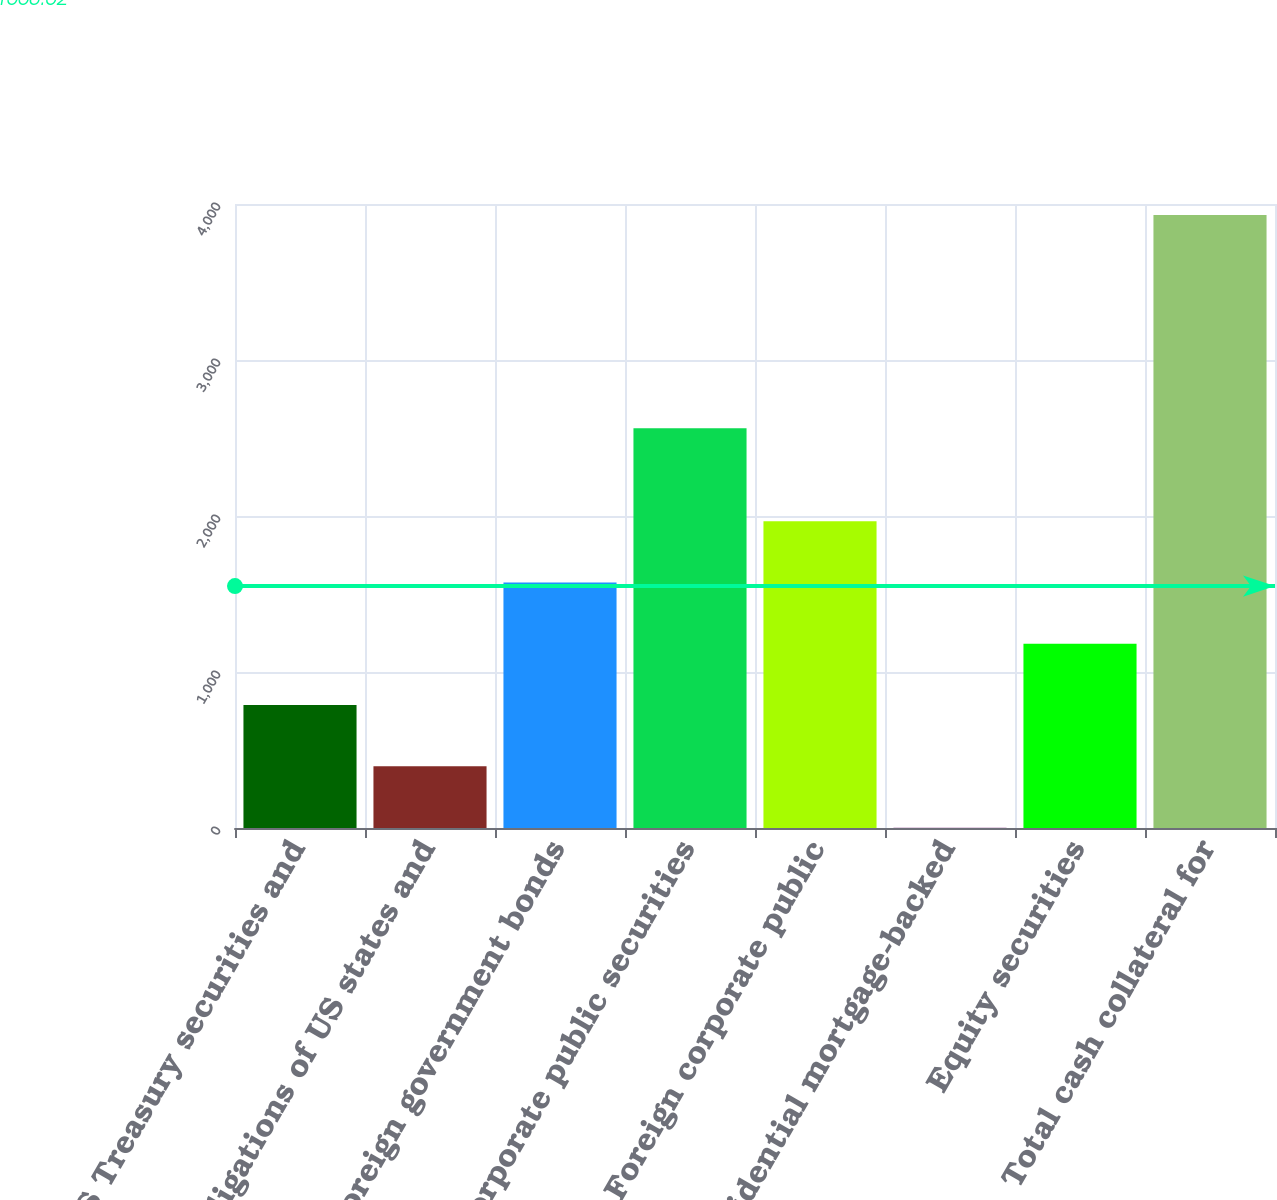<chart> <loc_0><loc_0><loc_500><loc_500><bar_chart><fcel>US Treasury securities and<fcel>Obligations of US states and<fcel>Foreign government bonds<fcel>US corporate public securities<fcel>Foreign corporate public<fcel>Residential mortgage-backed<fcel>Equity securities<fcel>Total cash collateral for<nl><fcel>789.12<fcel>396.63<fcel>1574.1<fcel>2563<fcel>1966.59<fcel>4.14<fcel>1181.61<fcel>3929<nl></chart> 